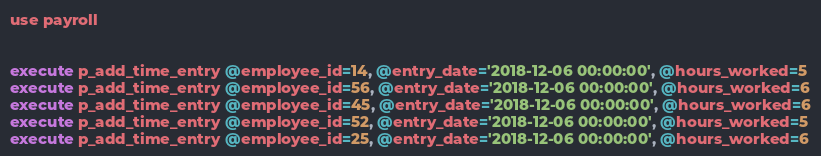<code> <loc_0><loc_0><loc_500><loc_500><_SQL_>use payroll


execute p_add_time_entry @employee_id=14, @entry_date='2018-12-06 00:00:00', @hours_worked=5
execute p_add_time_entry @employee_id=56, @entry_date='2018-12-06 00:00:00', @hours_worked=6
execute p_add_time_entry @employee_id=45, @entry_date='2018-12-06 00:00:00', @hours_worked=6
execute p_add_time_entry @employee_id=52, @entry_date='2018-12-06 00:00:00', @hours_worked=5
execute p_add_time_entry @employee_id=25, @entry_date='2018-12-06 00:00:00', @hours_worked=6

</code> 